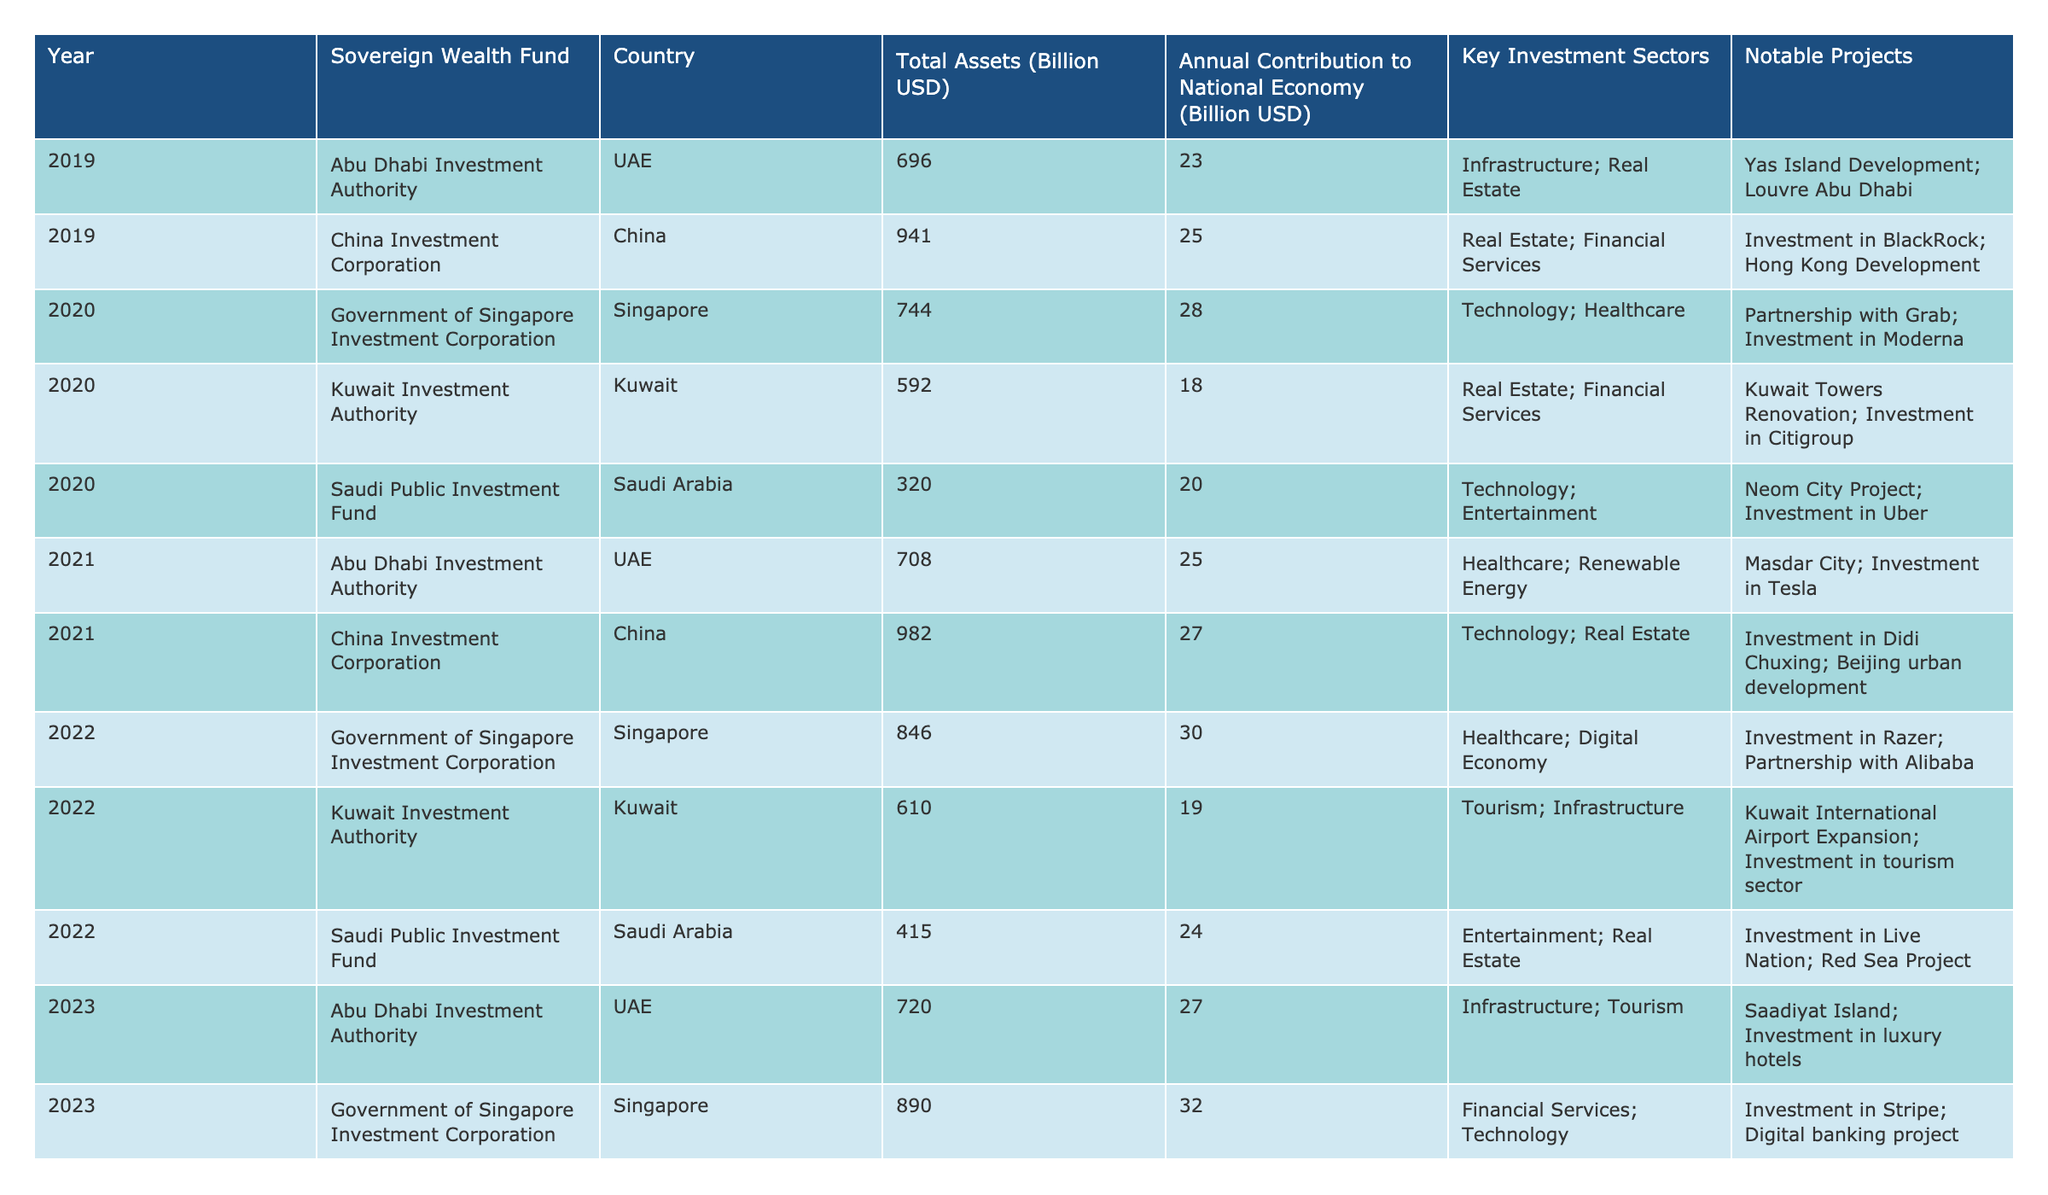What was the total assets value of the Government of Singapore Investment Corporation in 2020? According to the table, the Government of Singapore Investment Corporation had total assets worth 744 billion USD in 2020.
Answer: 744 billion USD Which Sovereign Wealth Fund contributed the least to the national economy in 2022? In 2022, the Kuwait Investment Authority contributed 19 billion USD, which is lower than the contributions from other funds in that year.
Answer: Kuwait Investment Authority What is the total annual contribution to the national economy from the Saudi Public Investment Fund from 2019 to 2023? Adding the contributions: 20 (2019) + 24 (2022) = 44 billion USD. The contributions from other years (2020, 2021, 2023) are not provided.
Answer: 44 billion USD Which country had the highest annual contribution to its national economy from a Sovereign Wealth Fund in 2023? The Government of Singapore Investment Corporation contributed 32 billion USD in 2023, which is the highest annual contribution reported.
Answer: 32 billion USD Did the total assets of the China Investment Corporation increase from 2019 to 2021? Yes, the total assets increased from 941 billion USD in 2019 to 982 billion USD in 2021, indicating growth over the two-year period.
Answer: Yes What was the average annual contribution to the national economy from the Abu Dhabi Investment Authority from 2019 to 2023? The contributions over those years are 23 (2019), 25 (2021), 27 (2023). Adding them gives a total of 75 billion USD over 3 years, resulting in an average of 75/3 = 25 billion USD.
Answer: 25 billion USD Which Sovereign Wealth Fund in 2020 focused on technology and healthcare? The Government of Singapore Investment Corporation focused on technology and healthcare in 2020, as indicated in the table.
Answer: Government of Singapore Investment Corporation What notable project is associated with the Kuwait Investment Authority in 2020? The notable project linked to the Kuwait Investment Authority in 2020 is the Kuwait Towers Renovation.
Answer: Kuwait Towers Renovation How many investment sectors were reported for the Saudi Public Investment Fund in 2022? The Saudi Public Investment Fund reported two investment sectors: entertainment and real estate.
Answer: Two sectors What was the difference in total assets of the Abu Dhabi Investment Authority between 2019 and 2023? The difference is calculated as 720 billion USD (2023) - 696 billion USD (2019) = 24 billion USD.
Answer: 24 billion USD Is it true that the China Investment Corporation invested in BlackRock? Yes, the data confirms that the China Investment Corporation made an investment in BlackRock, as stated in the notable projects.
Answer: Yes 